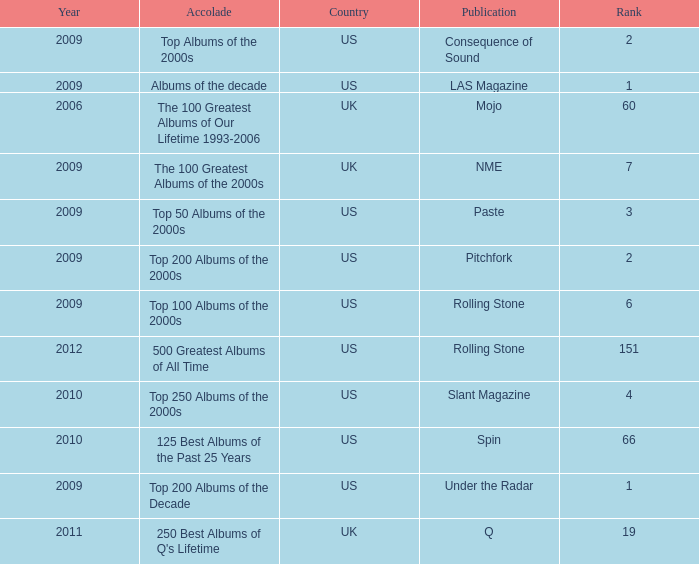What was the lowest rank after 2009 with an accolade of 125 best albums of the past 25 years? 66.0. 